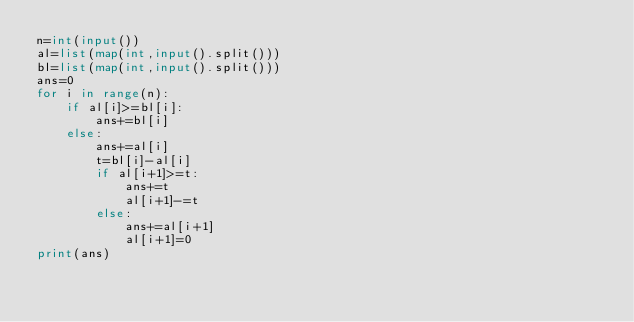<code> <loc_0><loc_0><loc_500><loc_500><_Python_>n=int(input())
al=list(map(int,input().split()))
bl=list(map(int,input().split()))
ans=0
for i in range(n):
    if al[i]>=bl[i]:
        ans+=bl[i]
    else:
        ans+=al[i]
        t=bl[i]-al[i]
        if al[i+1]>=t:
            ans+=t
            al[i+1]-=t
        else:
            ans+=al[i+1]
            al[i+1]=0
print(ans)</code> 